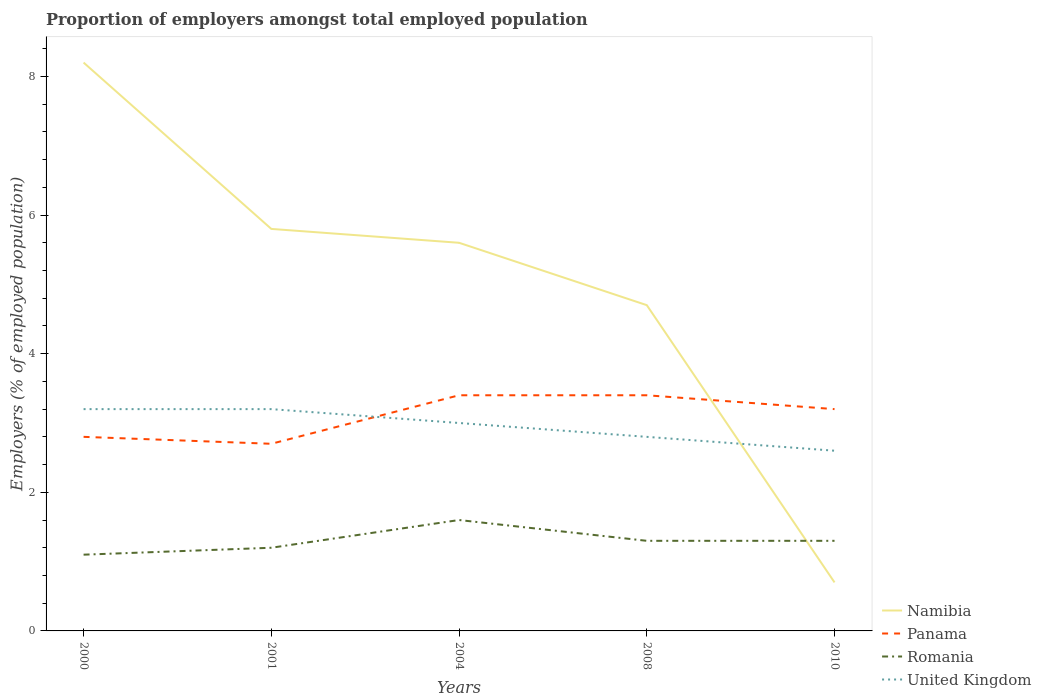Is the number of lines equal to the number of legend labels?
Keep it short and to the point. Yes. Across all years, what is the maximum proportion of employers in Romania?
Your answer should be compact. 1.1. What is the total proportion of employers in United Kingdom in the graph?
Provide a succinct answer. 0.4. What is the difference between the highest and the lowest proportion of employers in Romania?
Your answer should be compact. 1. How many lines are there?
Keep it short and to the point. 4. How many years are there in the graph?
Keep it short and to the point. 5. What is the difference between two consecutive major ticks on the Y-axis?
Your answer should be compact. 2. Does the graph contain any zero values?
Keep it short and to the point. No. Does the graph contain grids?
Provide a short and direct response. No. Where does the legend appear in the graph?
Provide a short and direct response. Bottom right. How many legend labels are there?
Ensure brevity in your answer.  4. What is the title of the graph?
Your answer should be very brief. Proportion of employers amongst total employed population. Does "Russian Federation" appear as one of the legend labels in the graph?
Offer a very short reply. No. What is the label or title of the X-axis?
Make the answer very short. Years. What is the label or title of the Y-axis?
Provide a succinct answer. Employers (% of employed population). What is the Employers (% of employed population) of Namibia in 2000?
Give a very brief answer. 8.2. What is the Employers (% of employed population) of Panama in 2000?
Offer a terse response. 2.8. What is the Employers (% of employed population) in Romania in 2000?
Offer a terse response. 1.1. What is the Employers (% of employed population) of United Kingdom in 2000?
Offer a very short reply. 3.2. What is the Employers (% of employed population) in Namibia in 2001?
Offer a very short reply. 5.8. What is the Employers (% of employed population) of Panama in 2001?
Provide a short and direct response. 2.7. What is the Employers (% of employed population) in Romania in 2001?
Offer a very short reply. 1.2. What is the Employers (% of employed population) in United Kingdom in 2001?
Provide a short and direct response. 3.2. What is the Employers (% of employed population) in Namibia in 2004?
Ensure brevity in your answer.  5.6. What is the Employers (% of employed population) of Panama in 2004?
Offer a terse response. 3.4. What is the Employers (% of employed population) of Romania in 2004?
Your answer should be very brief. 1.6. What is the Employers (% of employed population) of United Kingdom in 2004?
Keep it short and to the point. 3. What is the Employers (% of employed population) in Namibia in 2008?
Give a very brief answer. 4.7. What is the Employers (% of employed population) of Panama in 2008?
Offer a very short reply. 3.4. What is the Employers (% of employed population) of Romania in 2008?
Your answer should be compact. 1.3. What is the Employers (% of employed population) in United Kingdom in 2008?
Provide a succinct answer. 2.8. What is the Employers (% of employed population) in Namibia in 2010?
Keep it short and to the point. 0.7. What is the Employers (% of employed population) of Panama in 2010?
Give a very brief answer. 3.2. What is the Employers (% of employed population) in Romania in 2010?
Offer a very short reply. 1.3. What is the Employers (% of employed population) of United Kingdom in 2010?
Make the answer very short. 2.6. Across all years, what is the maximum Employers (% of employed population) of Namibia?
Provide a succinct answer. 8.2. Across all years, what is the maximum Employers (% of employed population) in Panama?
Make the answer very short. 3.4. Across all years, what is the maximum Employers (% of employed population) in Romania?
Provide a short and direct response. 1.6. Across all years, what is the maximum Employers (% of employed population) of United Kingdom?
Keep it short and to the point. 3.2. Across all years, what is the minimum Employers (% of employed population) of Namibia?
Offer a terse response. 0.7. Across all years, what is the minimum Employers (% of employed population) of Panama?
Give a very brief answer. 2.7. Across all years, what is the minimum Employers (% of employed population) of Romania?
Ensure brevity in your answer.  1.1. Across all years, what is the minimum Employers (% of employed population) of United Kingdom?
Offer a terse response. 2.6. What is the total Employers (% of employed population) in Panama in the graph?
Offer a very short reply. 15.5. What is the total Employers (% of employed population) of Romania in the graph?
Offer a very short reply. 6.5. What is the difference between the Employers (% of employed population) in Namibia in 2000 and that in 2001?
Ensure brevity in your answer.  2.4. What is the difference between the Employers (% of employed population) of Panama in 2000 and that in 2004?
Keep it short and to the point. -0.6. What is the difference between the Employers (% of employed population) in United Kingdom in 2000 and that in 2004?
Offer a terse response. 0.2. What is the difference between the Employers (% of employed population) in Panama in 2000 and that in 2008?
Offer a terse response. -0.6. What is the difference between the Employers (% of employed population) in Romania in 2000 and that in 2008?
Ensure brevity in your answer.  -0.2. What is the difference between the Employers (% of employed population) in United Kingdom in 2000 and that in 2008?
Ensure brevity in your answer.  0.4. What is the difference between the Employers (% of employed population) in Namibia in 2000 and that in 2010?
Make the answer very short. 7.5. What is the difference between the Employers (% of employed population) in Panama in 2000 and that in 2010?
Ensure brevity in your answer.  -0.4. What is the difference between the Employers (% of employed population) of Romania in 2000 and that in 2010?
Your response must be concise. -0.2. What is the difference between the Employers (% of employed population) of Namibia in 2001 and that in 2004?
Your response must be concise. 0.2. What is the difference between the Employers (% of employed population) of United Kingdom in 2001 and that in 2004?
Your answer should be very brief. 0.2. What is the difference between the Employers (% of employed population) of Namibia in 2001 and that in 2008?
Your response must be concise. 1.1. What is the difference between the Employers (% of employed population) of Panama in 2001 and that in 2008?
Offer a very short reply. -0.7. What is the difference between the Employers (% of employed population) of Romania in 2001 and that in 2008?
Offer a very short reply. -0.1. What is the difference between the Employers (% of employed population) in United Kingdom in 2001 and that in 2008?
Provide a short and direct response. 0.4. What is the difference between the Employers (% of employed population) of Namibia in 2001 and that in 2010?
Provide a short and direct response. 5.1. What is the difference between the Employers (% of employed population) in Romania in 2001 and that in 2010?
Your response must be concise. -0.1. What is the difference between the Employers (% of employed population) of United Kingdom in 2001 and that in 2010?
Your answer should be compact. 0.6. What is the difference between the Employers (% of employed population) of Panama in 2004 and that in 2008?
Offer a terse response. 0. What is the difference between the Employers (% of employed population) in Romania in 2004 and that in 2008?
Give a very brief answer. 0.3. What is the difference between the Employers (% of employed population) of Namibia in 2004 and that in 2010?
Give a very brief answer. 4.9. What is the difference between the Employers (% of employed population) of Panama in 2004 and that in 2010?
Provide a succinct answer. 0.2. What is the difference between the Employers (% of employed population) of Namibia in 2008 and that in 2010?
Your answer should be very brief. 4. What is the difference between the Employers (% of employed population) of Romania in 2008 and that in 2010?
Your response must be concise. 0. What is the difference between the Employers (% of employed population) in Panama in 2000 and the Employers (% of employed population) in Romania in 2001?
Ensure brevity in your answer.  1.6. What is the difference between the Employers (% of employed population) of Panama in 2000 and the Employers (% of employed population) of United Kingdom in 2001?
Your response must be concise. -0.4. What is the difference between the Employers (% of employed population) in Namibia in 2000 and the Employers (% of employed population) in Romania in 2004?
Your answer should be compact. 6.6. What is the difference between the Employers (% of employed population) in Namibia in 2000 and the Employers (% of employed population) in United Kingdom in 2004?
Your answer should be very brief. 5.2. What is the difference between the Employers (% of employed population) in Panama in 2000 and the Employers (% of employed population) in Romania in 2004?
Make the answer very short. 1.2. What is the difference between the Employers (% of employed population) of Panama in 2000 and the Employers (% of employed population) of United Kingdom in 2004?
Make the answer very short. -0.2. What is the difference between the Employers (% of employed population) in Romania in 2000 and the Employers (% of employed population) in United Kingdom in 2004?
Your response must be concise. -1.9. What is the difference between the Employers (% of employed population) of Namibia in 2000 and the Employers (% of employed population) of Panama in 2008?
Offer a very short reply. 4.8. What is the difference between the Employers (% of employed population) in Namibia in 2000 and the Employers (% of employed population) in Romania in 2008?
Your answer should be compact. 6.9. What is the difference between the Employers (% of employed population) of Namibia in 2000 and the Employers (% of employed population) of United Kingdom in 2008?
Offer a terse response. 5.4. What is the difference between the Employers (% of employed population) of Panama in 2000 and the Employers (% of employed population) of United Kingdom in 2008?
Provide a short and direct response. 0. What is the difference between the Employers (% of employed population) in Namibia in 2000 and the Employers (% of employed population) in Panama in 2010?
Make the answer very short. 5. What is the difference between the Employers (% of employed population) in Namibia in 2000 and the Employers (% of employed population) in Romania in 2010?
Provide a succinct answer. 6.9. What is the difference between the Employers (% of employed population) in Panama in 2000 and the Employers (% of employed population) in Romania in 2010?
Provide a succinct answer. 1.5. What is the difference between the Employers (% of employed population) of Panama in 2000 and the Employers (% of employed population) of United Kingdom in 2010?
Make the answer very short. 0.2. What is the difference between the Employers (% of employed population) of Namibia in 2001 and the Employers (% of employed population) of Panama in 2004?
Your response must be concise. 2.4. What is the difference between the Employers (% of employed population) in Namibia in 2001 and the Employers (% of employed population) in Romania in 2004?
Offer a terse response. 4.2. What is the difference between the Employers (% of employed population) in Panama in 2001 and the Employers (% of employed population) in Romania in 2004?
Provide a short and direct response. 1.1. What is the difference between the Employers (% of employed population) of Romania in 2001 and the Employers (% of employed population) of United Kingdom in 2004?
Offer a very short reply. -1.8. What is the difference between the Employers (% of employed population) of Namibia in 2001 and the Employers (% of employed population) of Panama in 2008?
Your answer should be very brief. 2.4. What is the difference between the Employers (% of employed population) of Namibia in 2001 and the Employers (% of employed population) of Romania in 2008?
Give a very brief answer. 4.5. What is the difference between the Employers (% of employed population) of Panama in 2001 and the Employers (% of employed population) of Romania in 2008?
Your response must be concise. 1.4. What is the difference between the Employers (% of employed population) of Romania in 2001 and the Employers (% of employed population) of United Kingdom in 2008?
Offer a terse response. -1.6. What is the difference between the Employers (% of employed population) of Romania in 2001 and the Employers (% of employed population) of United Kingdom in 2010?
Your response must be concise. -1.4. What is the difference between the Employers (% of employed population) of Namibia in 2004 and the Employers (% of employed population) of Panama in 2008?
Your response must be concise. 2.2. What is the difference between the Employers (% of employed population) of Panama in 2004 and the Employers (% of employed population) of Romania in 2008?
Provide a short and direct response. 2.1. What is the difference between the Employers (% of employed population) of Panama in 2004 and the Employers (% of employed population) of United Kingdom in 2010?
Keep it short and to the point. 0.8. What is the difference between the Employers (% of employed population) in Romania in 2004 and the Employers (% of employed population) in United Kingdom in 2010?
Your answer should be compact. -1. What is the difference between the Employers (% of employed population) of Namibia in 2008 and the Employers (% of employed population) of United Kingdom in 2010?
Keep it short and to the point. 2.1. What is the difference between the Employers (% of employed population) in Panama in 2008 and the Employers (% of employed population) in United Kingdom in 2010?
Provide a succinct answer. 0.8. What is the average Employers (% of employed population) in Panama per year?
Your response must be concise. 3.1. What is the average Employers (% of employed population) of Romania per year?
Your answer should be very brief. 1.3. What is the average Employers (% of employed population) of United Kingdom per year?
Give a very brief answer. 2.96. In the year 2000, what is the difference between the Employers (% of employed population) of Namibia and Employers (% of employed population) of Romania?
Make the answer very short. 7.1. In the year 2000, what is the difference between the Employers (% of employed population) of Panama and Employers (% of employed population) of United Kingdom?
Ensure brevity in your answer.  -0.4. In the year 2001, what is the difference between the Employers (% of employed population) in Namibia and Employers (% of employed population) in United Kingdom?
Your answer should be very brief. 2.6. In the year 2001, what is the difference between the Employers (% of employed population) in Panama and Employers (% of employed population) in Romania?
Your response must be concise. 1.5. In the year 2001, what is the difference between the Employers (% of employed population) in Panama and Employers (% of employed population) in United Kingdom?
Provide a succinct answer. -0.5. In the year 2004, what is the difference between the Employers (% of employed population) of Namibia and Employers (% of employed population) of Romania?
Provide a succinct answer. 4. In the year 2004, what is the difference between the Employers (% of employed population) in Namibia and Employers (% of employed population) in United Kingdom?
Ensure brevity in your answer.  2.6. In the year 2004, what is the difference between the Employers (% of employed population) in Panama and Employers (% of employed population) in Romania?
Offer a terse response. 1.8. In the year 2004, what is the difference between the Employers (% of employed population) in Panama and Employers (% of employed population) in United Kingdom?
Give a very brief answer. 0.4. In the year 2004, what is the difference between the Employers (% of employed population) of Romania and Employers (% of employed population) of United Kingdom?
Offer a terse response. -1.4. In the year 2008, what is the difference between the Employers (% of employed population) of Namibia and Employers (% of employed population) of Panama?
Provide a succinct answer. 1.3. In the year 2008, what is the difference between the Employers (% of employed population) in Namibia and Employers (% of employed population) in United Kingdom?
Keep it short and to the point. 1.9. In the year 2008, what is the difference between the Employers (% of employed population) in Romania and Employers (% of employed population) in United Kingdom?
Your answer should be very brief. -1.5. In the year 2010, what is the difference between the Employers (% of employed population) in Namibia and Employers (% of employed population) in United Kingdom?
Give a very brief answer. -1.9. In the year 2010, what is the difference between the Employers (% of employed population) in Panama and Employers (% of employed population) in Romania?
Offer a very short reply. 1.9. In the year 2010, what is the difference between the Employers (% of employed population) of Panama and Employers (% of employed population) of United Kingdom?
Keep it short and to the point. 0.6. What is the ratio of the Employers (% of employed population) in Namibia in 2000 to that in 2001?
Give a very brief answer. 1.41. What is the ratio of the Employers (% of employed population) of Panama in 2000 to that in 2001?
Keep it short and to the point. 1.04. What is the ratio of the Employers (% of employed population) in Romania in 2000 to that in 2001?
Provide a succinct answer. 0.92. What is the ratio of the Employers (% of employed population) of Namibia in 2000 to that in 2004?
Provide a short and direct response. 1.46. What is the ratio of the Employers (% of employed population) of Panama in 2000 to that in 2004?
Offer a terse response. 0.82. What is the ratio of the Employers (% of employed population) in Romania in 2000 to that in 2004?
Your answer should be compact. 0.69. What is the ratio of the Employers (% of employed population) in United Kingdom in 2000 to that in 2004?
Your response must be concise. 1.07. What is the ratio of the Employers (% of employed population) in Namibia in 2000 to that in 2008?
Your answer should be very brief. 1.74. What is the ratio of the Employers (% of employed population) of Panama in 2000 to that in 2008?
Your response must be concise. 0.82. What is the ratio of the Employers (% of employed population) in Romania in 2000 to that in 2008?
Your answer should be very brief. 0.85. What is the ratio of the Employers (% of employed population) in United Kingdom in 2000 to that in 2008?
Your response must be concise. 1.14. What is the ratio of the Employers (% of employed population) of Namibia in 2000 to that in 2010?
Your response must be concise. 11.71. What is the ratio of the Employers (% of employed population) in Romania in 2000 to that in 2010?
Keep it short and to the point. 0.85. What is the ratio of the Employers (% of employed population) of United Kingdom in 2000 to that in 2010?
Ensure brevity in your answer.  1.23. What is the ratio of the Employers (% of employed population) of Namibia in 2001 to that in 2004?
Your answer should be very brief. 1.04. What is the ratio of the Employers (% of employed population) in Panama in 2001 to that in 2004?
Provide a succinct answer. 0.79. What is the ratio of the Employers (% of employed population) in United Kingdom in 2001 to that in 2004?
Your answer should be compact. 1.07. What is the ratio of the Employers (% of employed population) of Namibia in 2001 to that in 2008?
Offer a terse response. 1.23. What is the ratio of the Employers (% of employed population) of Panama in 2001 to that in 2008?
Offer a terse response. 0.79. What is the ratio of the Employers (% of employed population) of United Kingdom in 2001 to that in 2008?
Your answer should be compact. 1.14. What is the ratio of the Employers (% of employed population) of Namibia in 2001 to that in 2010?
Your response must be concise. 8.29. What is the ratio of the Employers (% of employed population) of Panama in 2001 to that in 2010?
Provide a short and direct response. 0.84. What is the ratio of the Employers (% of employed population) in United Kingdom in 2001 to that in 2010?
Offer a terse response. 1.23. What is the ratio of the Employers (% of employed population) in Namibia in 2004 to that in 2008?
Ensure brevity in your answer.  1.19. What is the ratio of the Employers (% of employed population) of Romania in 2004 to that in 2008?
Your answer should be very brief. 1.23. What is the ratio of the Employers (% of employed population) of United Kingdom in 2004 to that in 2008?
Offer a very short reply. 1.07. What is the ratio of the Employers (% of employed population) in Panama in 2004 to that in 2010?
Your answer should be compact. 1.06. What is the ratio of the Employers (% of employed population) in Romania in 2004 to that in 2010?
Keep it short and to the point. 1.23. What is the ratio of the Employers (% of employed population) in United Kingdom in 2004 to that in 2010?
Ensure brevity in your answer.  1.15. What is the ratio of the Employers (% of employed population) in Namibia in 2008 to that in 2010?
Offer a very short reply. 6.71. What is the ratio of the Employers (% of employed population) of United Kingdom in 2008 to that in 2010?
Keep it short and to the point. 1.08. What is the difference between the highest and the lowest Employers (% of employed population) in Namibia?
Provide a succinct answer. 7.5. 